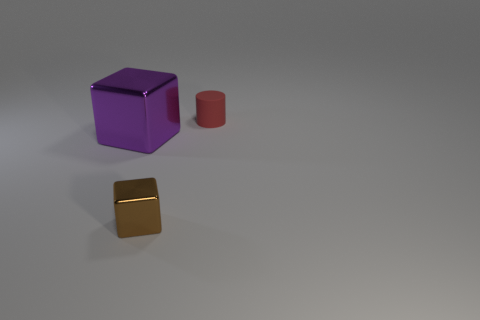What size is the object that is to the right of the metal cube that is right of the large metal object?
Keep it short and to the point. Small. What number of things are either large metal objects or small yellow rubber things?
Your answer should be compact. 1. Are there any metal blocks of the same color as the tiny metallic thing?
Your response must be concise. No. Is the number of purple cubes less than the number of blue rubber cylinders?
Make the answer very short. No. What number of things are either tiny yellow metallic objects or metallic cubes that are on the right side of the purple metal object?
Provide a short and direct response. 1. Are there any purple objects that have the same material as the tiny brown object?
Provide a short and direct response. Yes. What is the material of the brown object that is the same size as the red cylinder?
Your answer should be compact. Metal. What is the material of the cube behind the small thing in front of the cylinder?
Provide a succinct answer. Metal. There is a thing that is on the left side of the small metal cube; is it the same shape as the tiny brown metal thing?
Provide a short and direct response. Yes. There is a large block that is made of the same material as the brown object; what color is it?
Keep it short and to the point. Purple. 